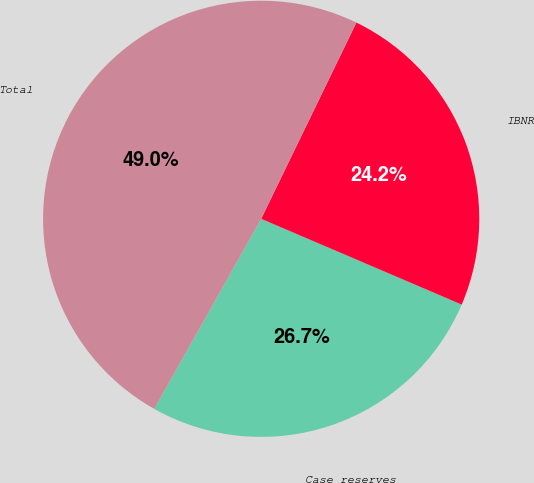Convert chart to OTSL. <chart><loc_0><loc_0><loc_500><loc_500><pie_chart><fcel>Case reserves<fcel>IBNR<fcel>Total<nl><fcel>26.72%<fcel>24.24%<fcel>49.03%<nl></chart> 